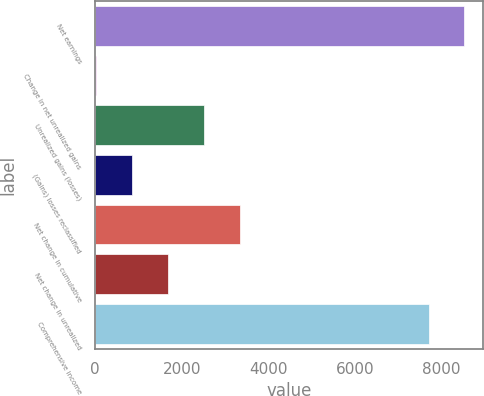<chart> <loc_0><loc_0><loc_500><loc_500><bar_chart><fcel>Net earnings<fcel>Change in net unrealized gains<fcel>Unrealized gains (losses)<fcel>(Gains) losses reclassified<fcel>Net change in cumulative<fcel>Net change in unrealized<fcel>Comprehensive income<nl><fcel>8536.2<fcel>17<fcel>2510.6<fcel>848.2<fcel>3341.8<fcel>1679.4<fcel>7705<nl></chart> 